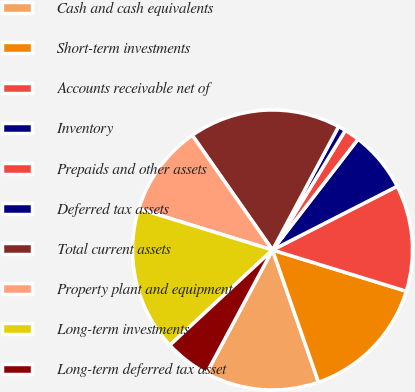<chart> <loc_0><loc_0><loc_500><loc_500><pie_chart><fcel>Cash and cash equivalents<fcel>Short-term investments<fcel>Accounts receivable net of<fcel>Inventory<fcel>Prepaids and other assets<fcel>Deferred tax assets<fcel>Total current assets<fcel>Property plant and equipment<fcel>Long-term investments<fcel>Long-term deferred tax asset<nl><fcel>13.16%<fcel>14.91%<fcel>12.28%<fcel>7.02%<fcel>1.76%<fcel>0.88%<fcel>17.54%<fcel>10.53%<fcel>16.66%<fcel>5.27%<nl></chart> 